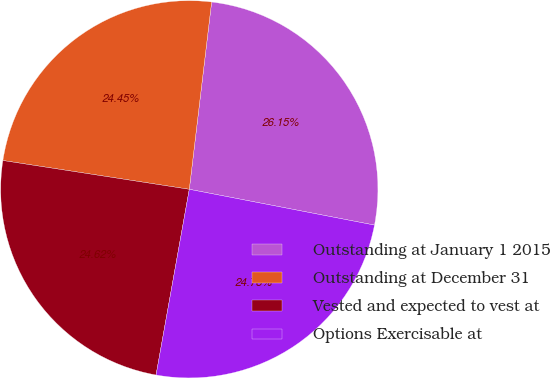Convert chart. <chart><loc_0><loc_0><loc_500><loc_500><pie_chart><fcel>Outstanding at January 1 2015<fcel>Outstanding at December 31<fcel>Vested and expected to vest at<fcel>Options Exercisable at<nl><fcel>26.15%<fcel>24.45%<fcel>24.62%<fcel>24.78%<nl></chart> 